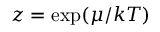<formula> <loc_0><loc_0><loc_500><loc_500>z = \exp ( \mu / k T )</formula> 